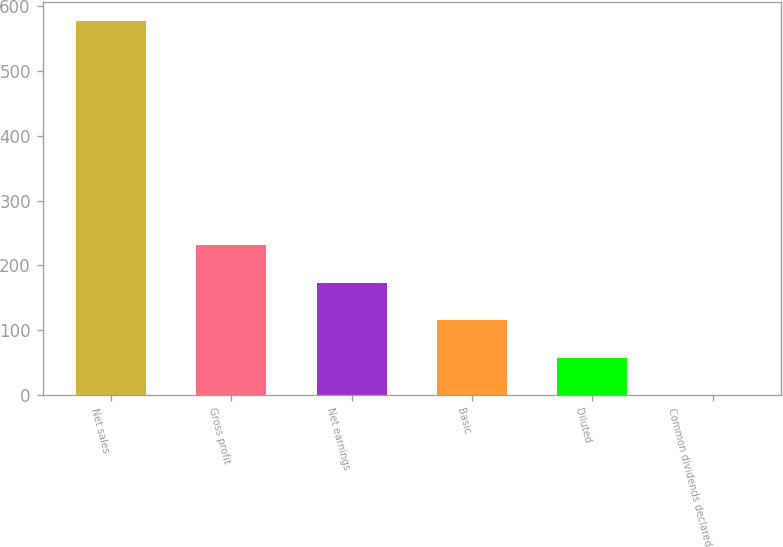<chart> <loc_0><loc_0><loc_500><loc_500><bar_chart><fcel>Net sales<fcel>Gross profit<fcel>Net earnings<fcel>Basic<fcel>Diluted<fcel>Common dividends declared<nl><fcel>577.2<fcel>230.97<fcel>173.27<fcel>115.57<fcel>57.87<fcel>0.17<nl></chart> 